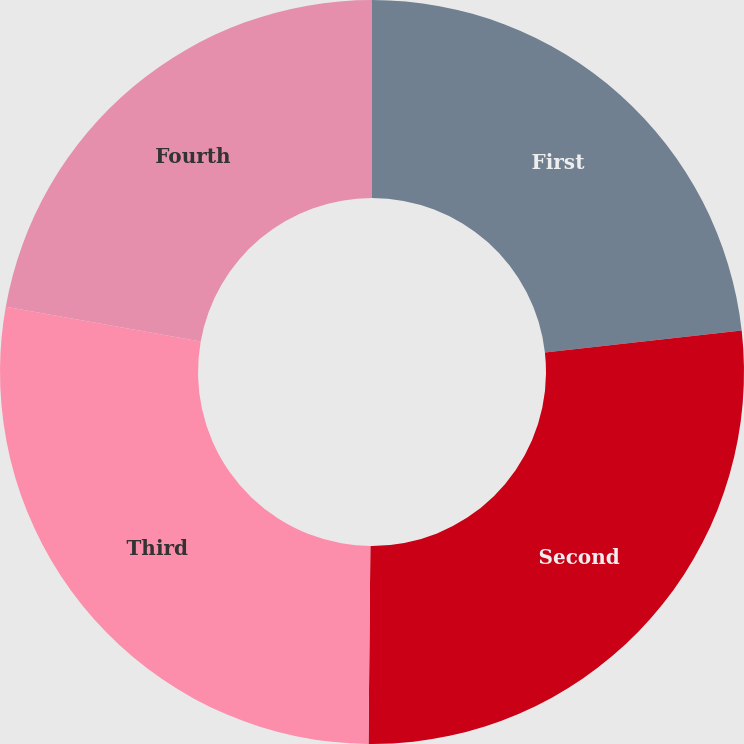Convert chart to OTSL. <chart><loc_0><loc_0><loc_500><loc_500><pie_chart><fcel>First<fcel>Second<fcel>Third<fcel>Fourth<nl><fcel>23.22%<fcel>26.93%<fcel>27.66%<fcel>22.19%<nl></chart> 